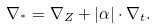<formula> <loc_0><loc_0><loc_500><loc_500>\nabla _ { ^ { * } } = \nabla _ { Z } + | \alpha | \cdot \nabla _ { t } .</formula> 